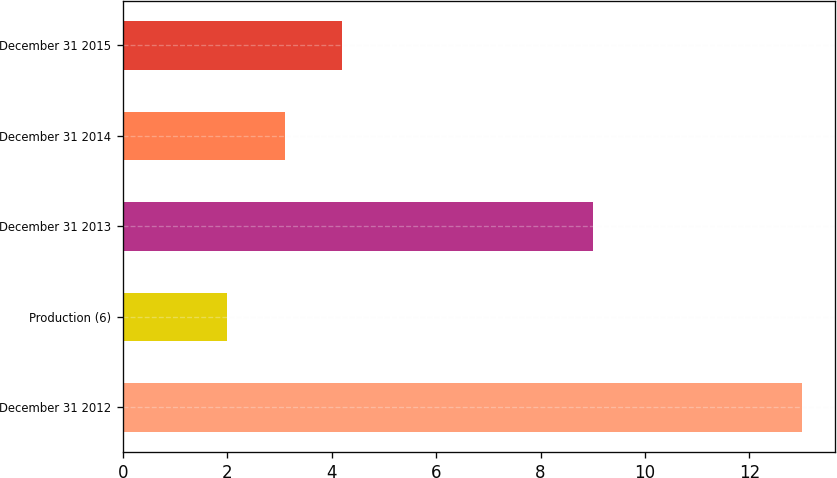Convert chart. <chart><loc_0><loc_0><loc_500><loc_500><bar_chart><fcel>December 31 2012<fcel>Production (6)<fcel>December 31 2013<fcel>December 31 2014<fcel>December 31 2015<nl><fcel>13<fcel>2<fcel>9<fcel>3.1<fcel>4.2<nl></chart> 